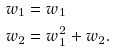<formula> <loc_0><loc_0><loc_500><loc_500>\ w _ { 1 } & = w _ { 1 } \\ \ w _ { 2 } & = w _ { 1 } ^ { 2 } + w _ { 2 } .</formula> 